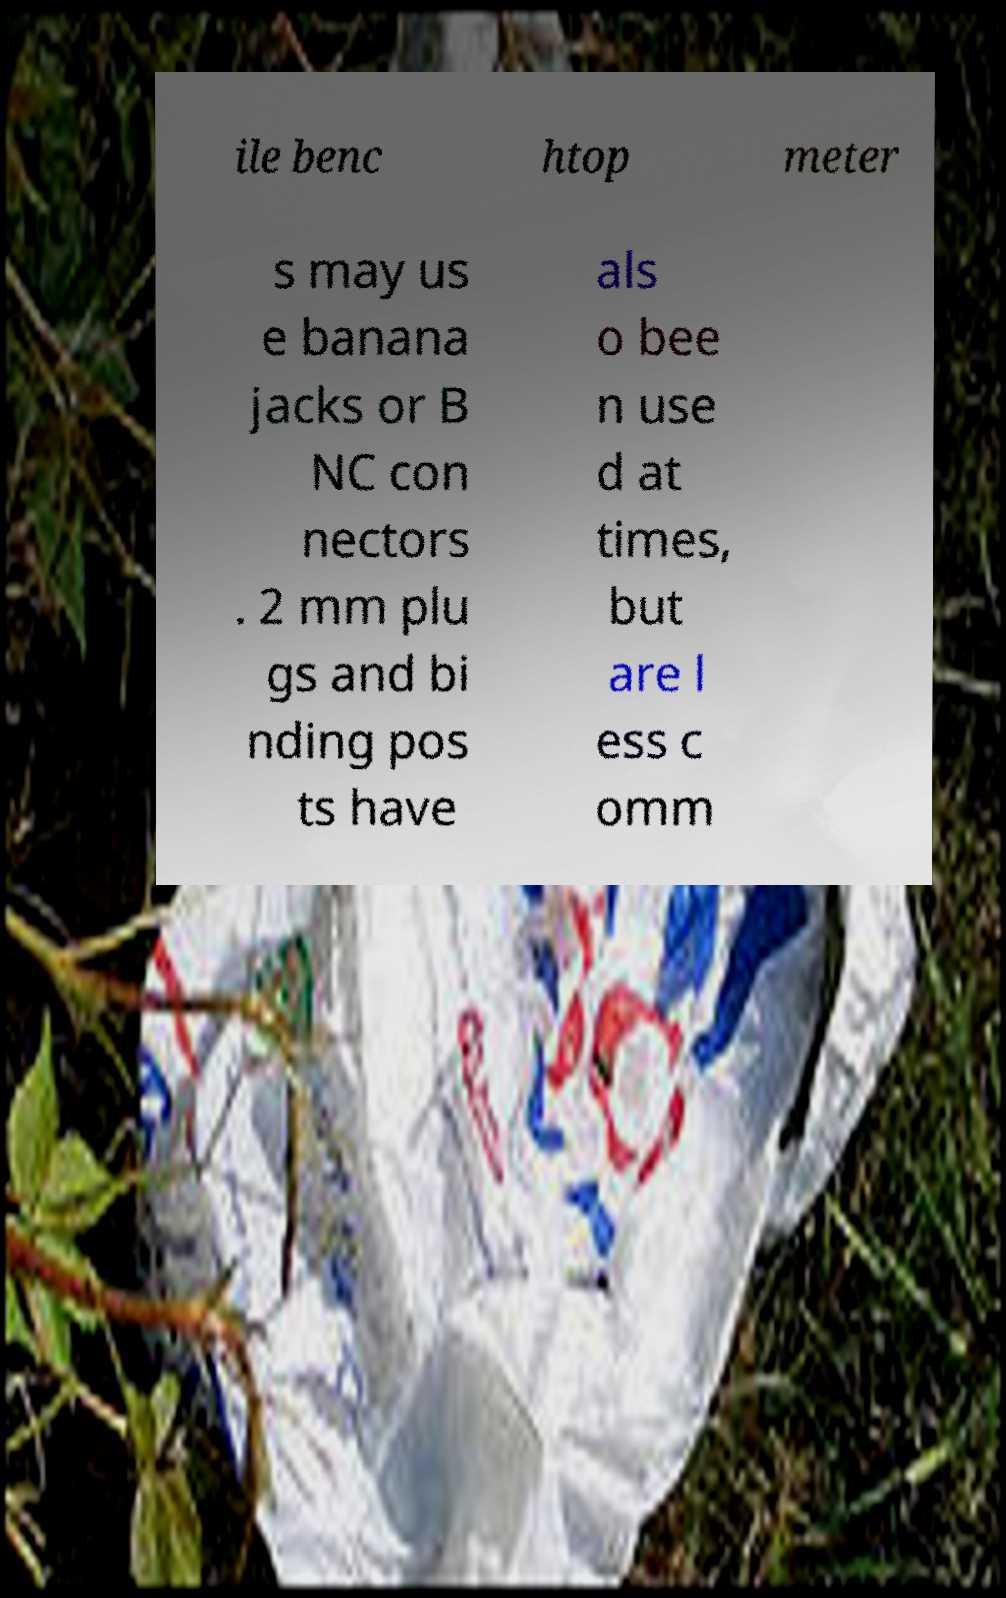Please identify and transcribe the text found in this image. ile benc htop meter s may us e banana jacks or B NC con nectors . 2 mm plu gs and bi nding pos ts have als o bee n use d at times, but are l ess c omm 